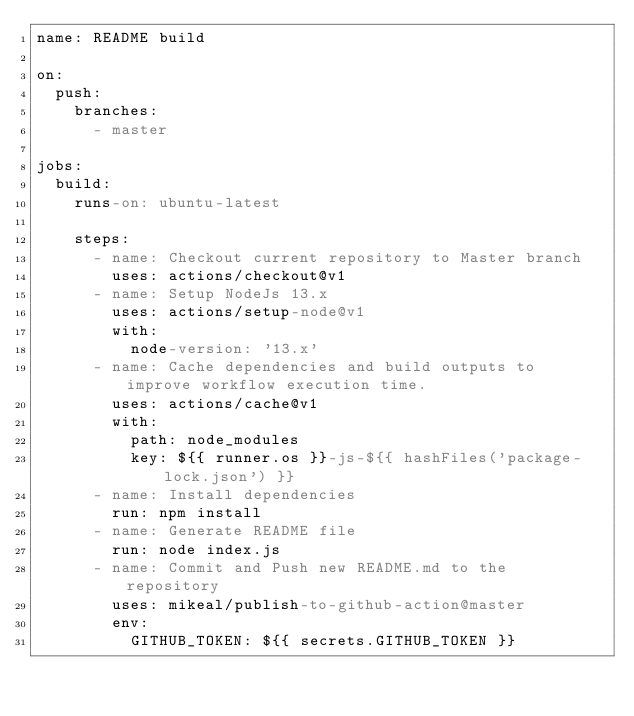Convert code to text. <code><loc_0><loc_0><loc_500><loc_500><_YAML_>name: README build

on:
  push:
    branches:
      - master

jobs:
  build:
    runs-on: ubuntu-latest

    steps:
      - name: Checkout current repository to Master branch
        uses: actions/checkout@v1
      - name: Setup NodeJs 13.x
        uses: actions/setup-node@v1
        with:
          node-version: '13.x'
      - name: Cache dependencies and build outputs to improve workflow execution time.
        uses: actions/cache@v1
        with:
          path: node_modules
          key: ${{ runner.os }}-js-${{ hashFiles('package-lock.json') }}
      - name: Install dependencies
        run: npm install
      - name: Generate README file
        run: node index.js
      - name: Commit and Push new README.md to the repository
        uses: mikeal/publish-to-github-action@master
        env:
          GITHUB_TOKEN: ${{ secrets.GITHUB_TOKEN }}</code> 